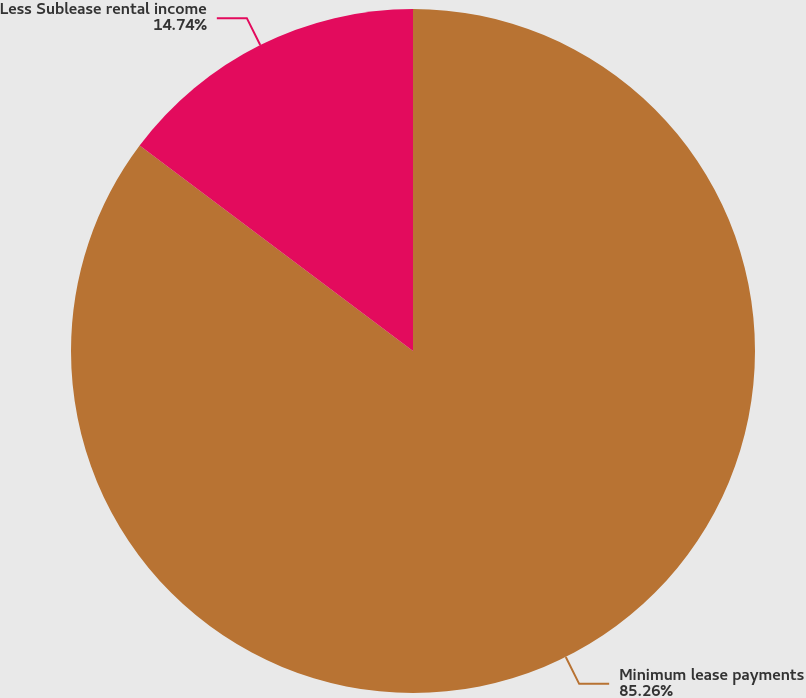Convert chart. <chart><loc_0><loc_0><loc_500><loc_500><pie_chart><fcel>Minimum lease payments<fcel>Less Sublease rental income<nl><fcel>85.26%<fcel>14.74%<nl></chart> 